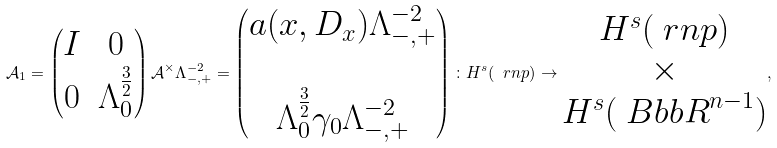Convert formula to latex. <formula><loc_0><loc_0><loc_500><loc_500>\mathcal { A } _ { 1 } = \begin{pmatrix} I & 0 \\ 0 & \Lambda _ { 0 } ^ { \frac { 3 } { 2 } } \end{pmatrix} \mathcal { A } ^ { \times } \Lambda _ { - , + } ^ { - 2 } = \begin{pmatrix} a ( x , D _ { x } ) \Lambda _ { - , + } ^ { - 2 } \\ \quad \\ \Lambda _ { 0 } ^ { \frac { 3 } { 2 } } \gamma _ { 0 } \Lambda _ { - , + } ^ { - 2 } \end{pmatrix} \colon H ^ { s } ( \ r n p ) \to \begin{matrix} H ^ { s } ( \ r n p ) \\ \times \\ H ^ { s } ( { \ B b b R } ^ { n - 1 } ) \end{matrix} ,</formula> 